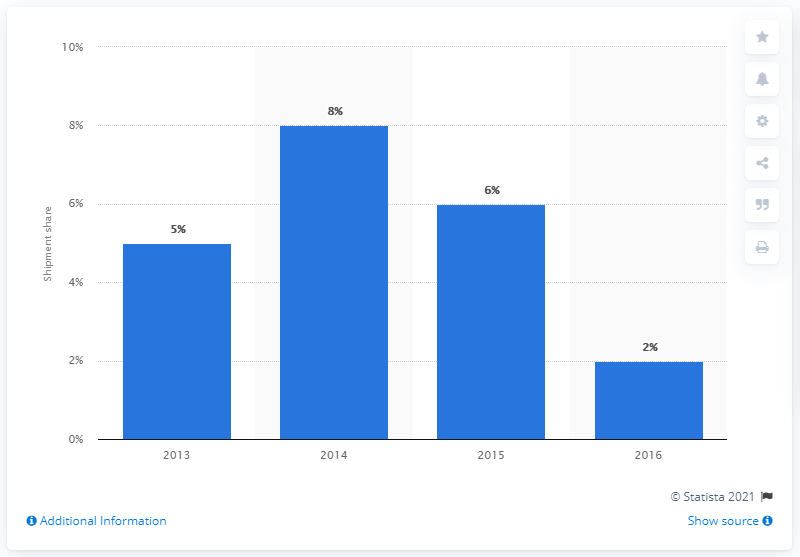Highlight a few significant elements in this photo. What was Misfit's shipment share in 2016? According to the data, Misfit's shipment share in 2016 was 2.%. 